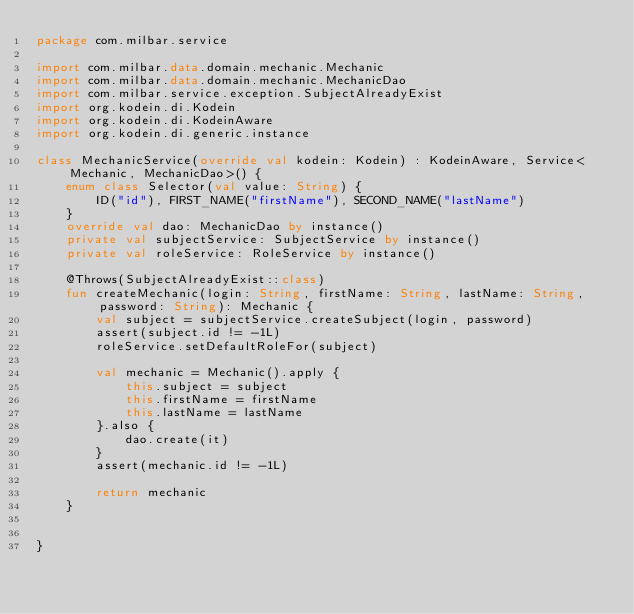<code> <loc_0><loc_0><loc_500><loc_500><_Kotlin_>package com.milbar.service

import com.milbar.data.domain.mechanic.Mechanic
import com.milbar.data.domain.mechanic.MechanicDao
import com.milbar.service.exception.SubjectAlreadyExist
import org.kodein.di.Kodein
import org.kodein.di.KodeinAware
import org.kodein.di.generic.instance

class MechanicService(override val kodein: Kodein) : KodeinAware, Service<Mechanic, MechanicDao>() {
    enum class Selector(val value: String) {
        ID("id"), FIRST_NAME("firstName"), SECOND_NAME("lastName")
    }
    override val dao: MechanicDao by instance()
    private val subjectService: SubjectService by instance()
    private val roleService: RoleService by instance()

    @Throws(SubjectAlreadyExist::class)
    fun createMechanic(login: String, firstName: String, lastName: String, password: String): Mechanic {
        val subject = subjectService.createSubject(login, password)
        assert(subject.id != -1L)
        roleService.setDefaultRoleFor(subject)

        val mechanic = Mechanic().apply {
            this.subject = subject
            this.firstName = firstName
            this.lastName = lastName
        }.also {
            dao.create(it)
        }
        assert(mechanic.id != -1L)

        return mechanic
    }


}</code> 